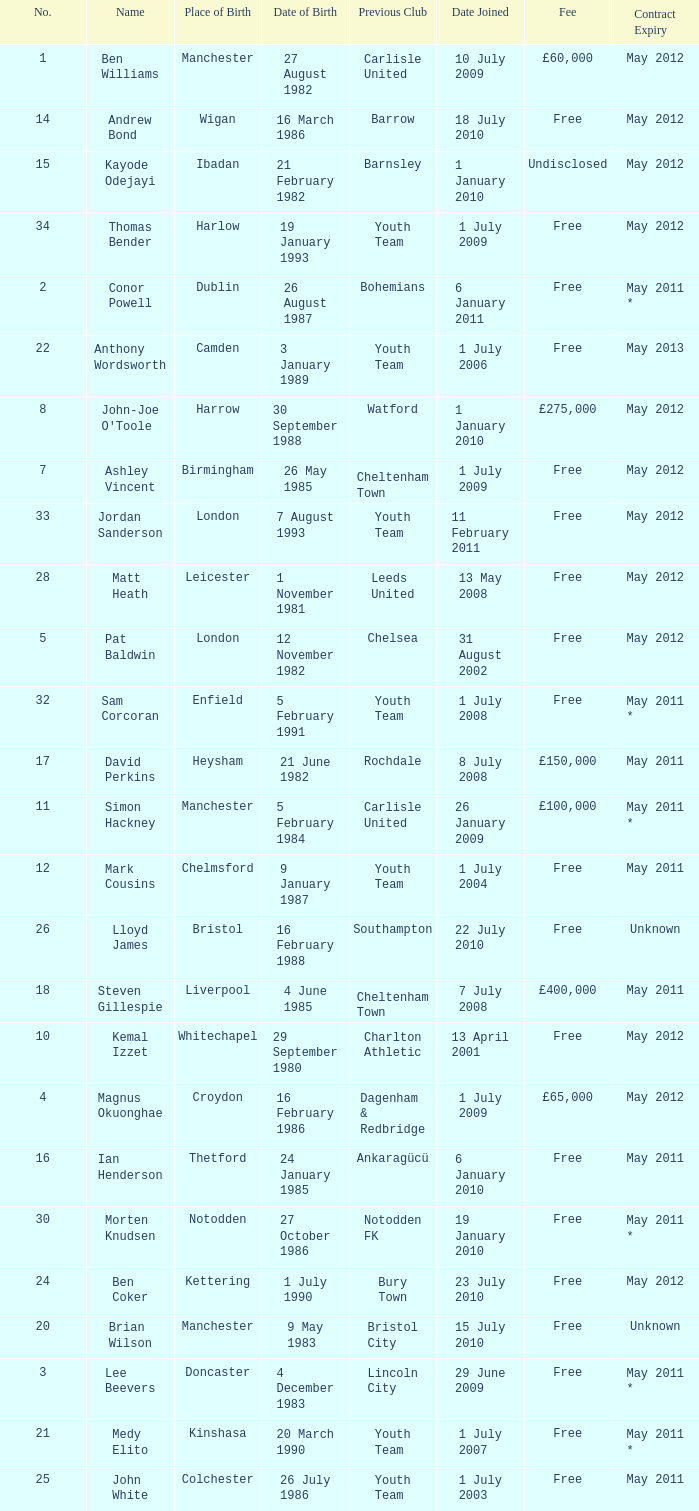What is the fee for ankaragücü previous club Free. Write the full table. {'header': ['No.', 'Name', 'Place of Birth', 'Date of Birth', 'Previous Club', 'Date Joined', 'Fee', 'Contract Expiry'], 'rows': [['1', 'Ben Williams', 'Manchester', '27 August 1982', 'Carlisle United', '10 July 2009', '£60,000', 'May 2012'], ['14', 'Andrew Bond', 'Wigan', '16 March 1986', 'Barrow', '18 July 2010', 'Free', 'May 2012'], ['15', 'Kayode Odejayi', 'Ibadan', '21 February 1982', 'Barnsley', '1 January 2010', 'Undisclosed', 'May 2012'], ['34', 'Thomas Bender', 'Harlow', '19 January 1993', 'Youth Team', '1 July 2009', 'Free', 'May 2012'], ['2', 'Conor Powell', 'Dublin', '26 August 1987', 'Bohemians', '6 January 2011', 'Free', 'May 2011 *'], ['22', 'Anthony Wordsworth', 'Camden', '3 January 1989', 'Youth Team', '1 July 2006', 'Free', 'May 2013'], ['8', "John-Joe O'Toole", 'Harrow', '30 September 1988', 'Watford', '1 January 2010', '£275,000', 'May 2012'], ['7', 'Ashley Vincent', 'Birmingham', '26 May 1985', 'Cheltenham Town', '1 July 2009', 'Free', 'May 2012'], ['33', 'Jordan Sanderson', 'London', '7 August 1993', 'Youth Team', '11 February 2011', 'Free', 'May 2012'], ['28', 'Matt Heath', 'Leicester', '1 November 1981', 'Leeds United', '13 May 2008', 'Free', 'May 2012'], ['5', 'Pat Baldwin', 'London', '12 November 1982', 'Chelsea', '31 August 2002', 'Free', 'May 2012'], ['32', 'Sam Corcoran', 'Enfield', '5 February 1991', 'Youth Team', '1 July 2008', 'Free', 'May 2011 *'], ['17', 'David Perkins', 'Heysham', '21 June 1982', 'Rochdale', '8 July 2008', '£150,000', 'May 2011'], ['11', 'Simon Hackney', 'Manchester', '5 February 1984', 'Carlisle United', '26 January 2009', '£100,000', 'May 2011 *'], ['12', 'Mark Cousins', 'Chelmsford', '9 January 1987', 'Youth Team', '1 July 2004', 'Free', 'May 2011'], ['26', 'Lloyd James', 'Bristol', '16 February 1988', 'Southampton', '22 July 2010', 'Free', 'Unknown'], ['18', 'Steven Gillespie', 'Liverpool', '4 June 1985', 'Cheltenham Town', '7 July 2008', '£400,000', 'May 2011'], ['10', 'Kemal Izzet', 'Whitechapel', '29 September 1980', 'Charlton Athletic', '13 April 2001', 'Free', 'May 2012'], ['4', 'Magnus Okuonghae', 'Croydon', '16 February 1986', 'Dagenham & Redbridge', '1 July 2009', '£65,000', 'May 2012'], ['16', 'Ian Henderson', 'Thetford', '24 January 1985', 'Ankaragücü', '6 January 2010', 'Free', 'May 2011'], ['30', 'Morten Knudsen', 'Notodden', '27 October 1986', 'Notodden FK', '19 January 2010', 'Free', 'May 2011 *'], ['24', 'Ben Coker', 'Kettering', '1 July 1990', 'Bury Town', '23 July 2010', 'Free', 'May 2012'], ['20', 'Brian Wilson', 'Manchester', '9 May 1983', 'Bristol City', '15 July 2010', 'Free', 'Unknown'], ['3', 'Lee Beevers', 'Doncaster', '4 December 1983', 'Lincoln City', '29 June 2009', 'Free', 'May 2011 *'], ['21', 'Medy Elito', 'Kinshasa', '20 March 1990', 'Youth Team', '1 July 2007', 'Free', 'May 2011 *'], ['25', 'John White', 'Colchester', '26 July 1986', 'Youth Team', '1 July 2003', 'Free', 'May 2011']]} 